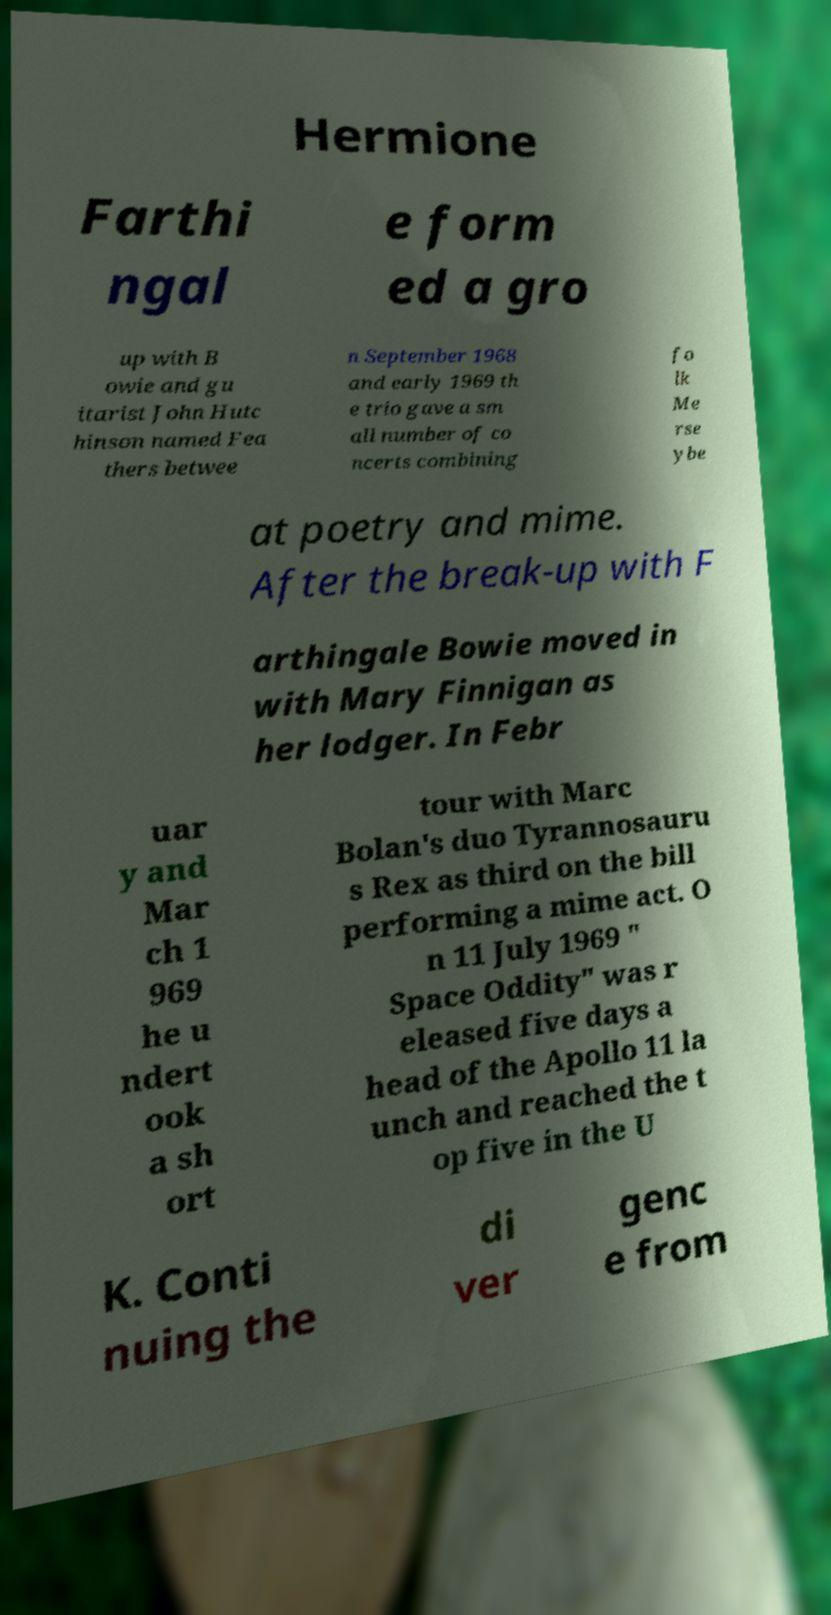Could you assist in decoding the text presented in this image and type it out clearly? Hermione Farthi ngal e form ed a gro up with B owie and gu itarist John Hutc hinson named Fea thers betwee n September 1968 and early 1969 th e trio gave a sm all number of co ncerts combining fo lk Me rse ybe at poetry and mime. After the break-up with F arthingale Bowie moved in with Mary Finnigan as her lodger. In Febr uar y and Mar ch 1 969 he u ndert ook a sh ort tour with Marc Bolan's duo Tyrannosauru s Rex as third on the bill performing a mime act. O n 11 July 1969 " Space Oddity" was r eleased five days a head of the Apollo 11 la unch and reached the t op five in the U K. Conti nuing the di ver genc e from 